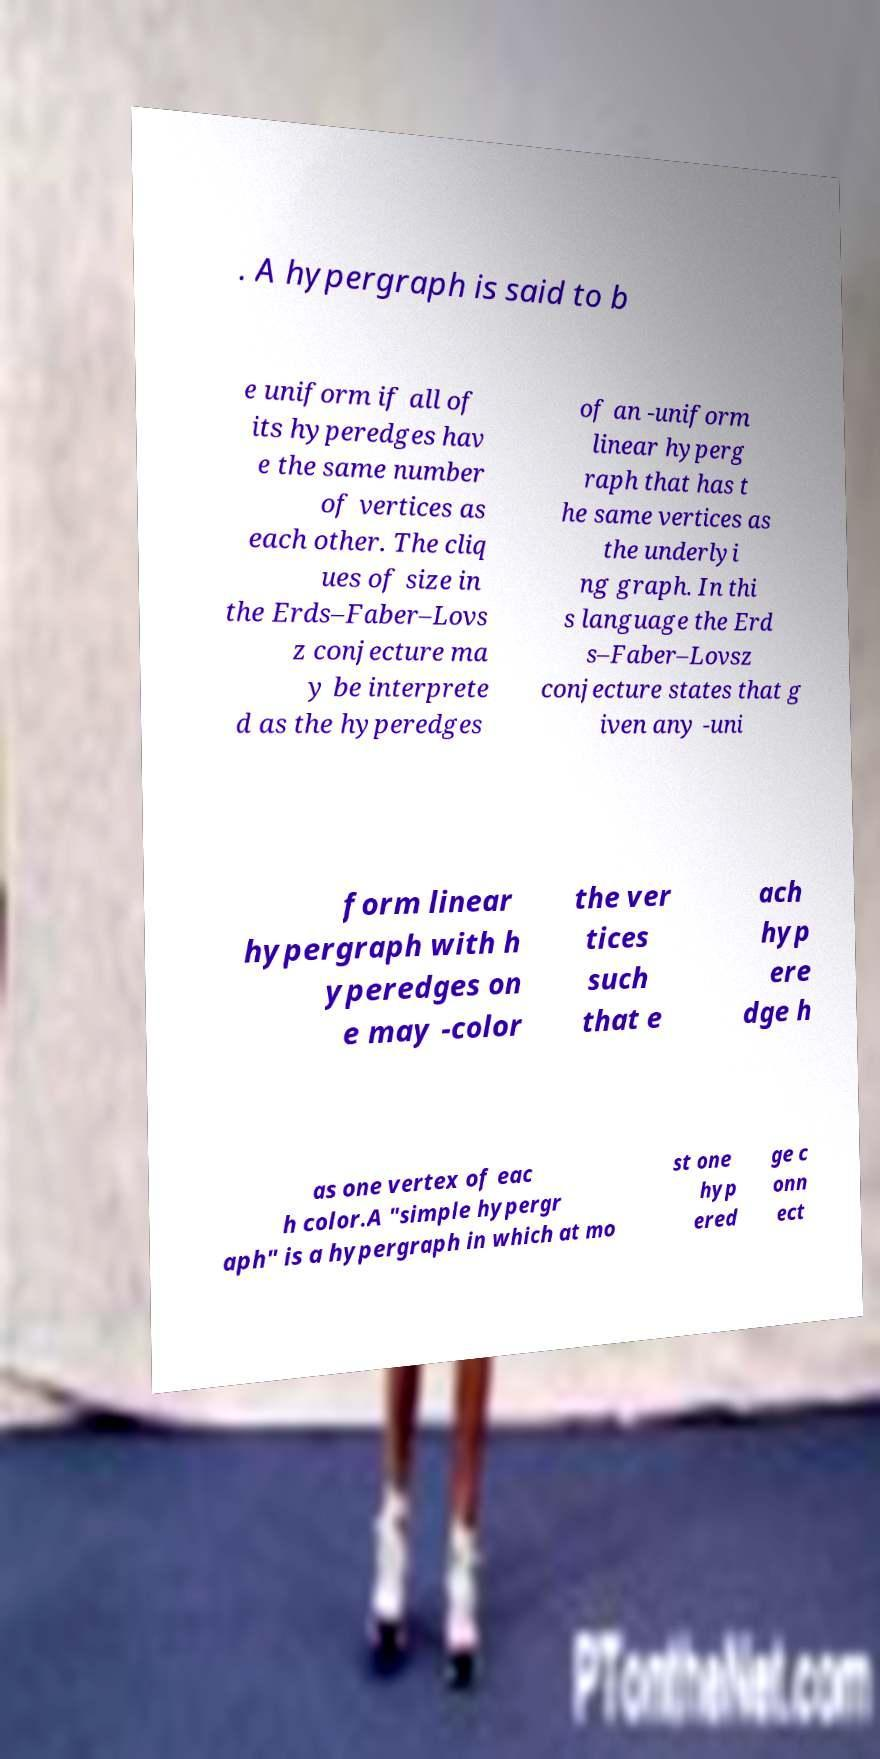Please identify and transcribe the text found in this image. . A hypergraph is said to b e uniform if all of its hyperedges hav e the same number of vertices as each other. The cliq ues of size in the Erds–Faber–Lovs z conjecture ma y be interprete d as the hyperedges of an -uniform linear hyperg raph that has t he same vertices as the underlyi ng graph. In thi s language the Erd s–Faber–Lovsz conjecture states that g iven any -uni form linear hypergraph with h yperedges on e may -color the ver tices such that e ach hyp ere dge h as one vertex of eac h color.A "simple hypergr aph" is a hypergraph in which at mo st one hyp ered ge c onn ect 